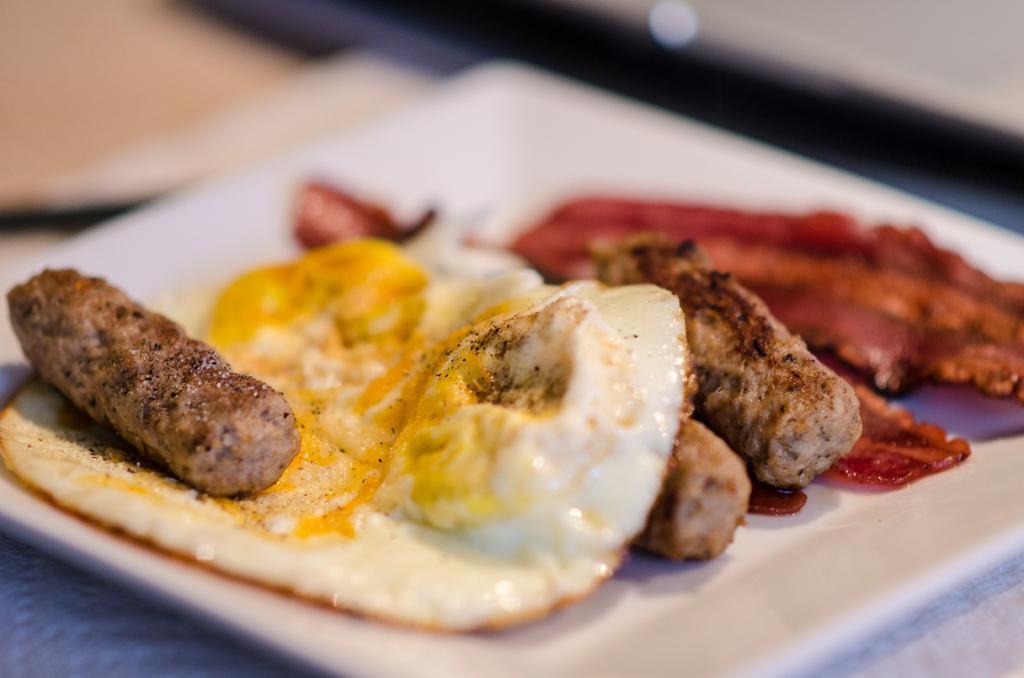In one or two sentences, can you explain what this image depicts? This image consists of a food kept in a plate. There is an egg omelette along with flesh in the plate. The plate is kept on a table. 